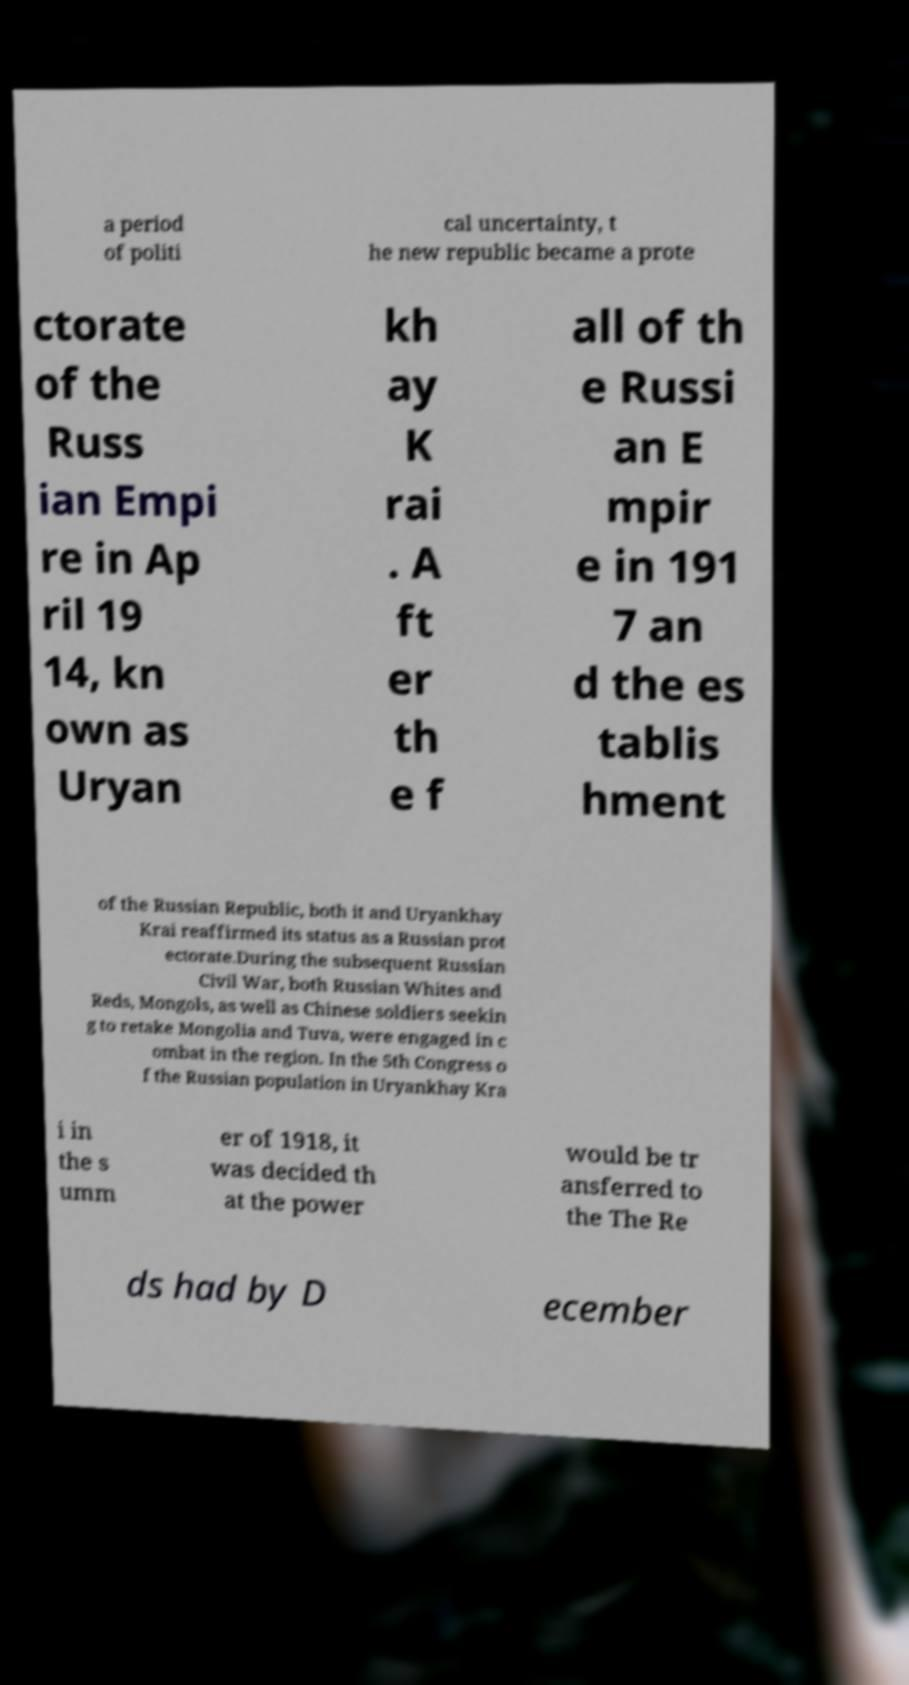What messages or text are displayed in this image? I need them in a readable, typed format. a period of politi cal uncertainty, t he new republic became a prote ctorate of the Russ ian Empi re in Ap ril 19 14, kn own as Uryan kh ay K rai . A ft er th e f all of th e Russi an E mpir e in 191 7 an d the es tablis hment of the Russian Republic, both it and Uryankhay Krai reaffirmed its status as a Russian prot ectorate.During the subsequent Russian Civil War, both Russian Whites and Reds, Mongols, as well as Chinese soldiers seekin g to retake Mongolia and Tuva, were engaged in c ombat in the region. In the 5th Congress o f the Russian population in Uryankhay Kra i in the s umm er of 1918, it was decided th at the power would be tr ansferred to the The Re ds had by D ecember 